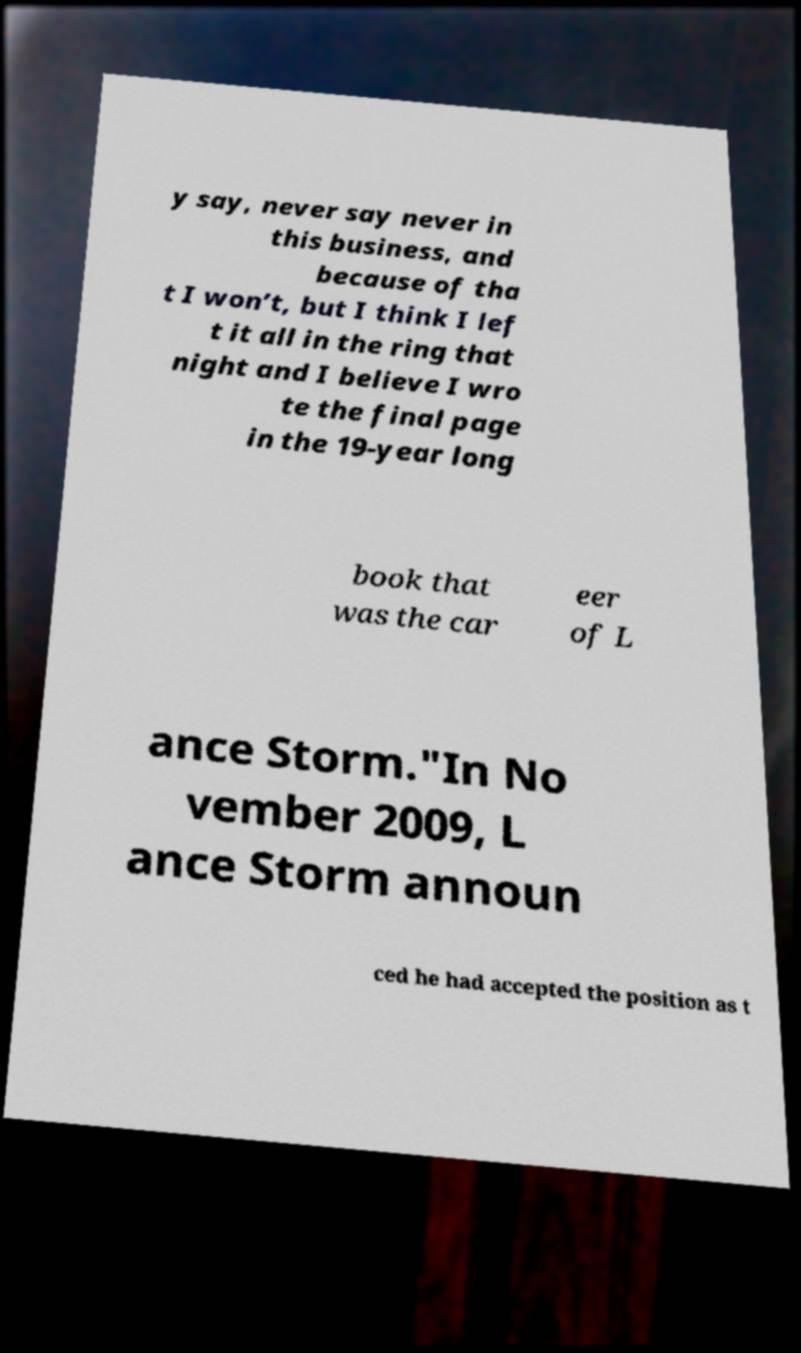Can you accurately transcribe the text from the provided image for me? y say, never say never in this business, and because of tha t I won’t, but I think I lef t it all in the ring that night and I believe I wro te the final page in the 19-year long book that was the car eer of L ance Storm."In No vember 2009, L ance Storm announ ced he had accepted the position as t 